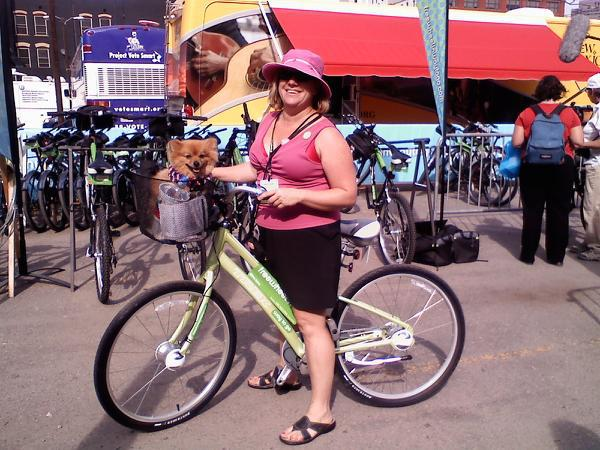Question: where are more bicycles parked?
Choices:
A. Next to the school.
B. In the bike rack.
C. By the recreation center.
D. Outside the garage.
Answer with the letter. Answer: B Question: who is wearing a blue backpack?
Choices:
A. The young student.
B. A person in the background.
C. The hiker in the forest.
D. The boy on the bike.
Answer with the letter. Answer: B Question: why is the woman wearing a hat?
Choices:
A. To keep the sun out of her eyes.
B. To protect her face from the sun.
C. To protect her hair dye from fading.
D. To keep the sun off her head.
Answer with the letter. Answer: D Question: what kind of shoes is she wearing?
Choices:
A. High heels.
B. Flip flops.
C. Sneakers.
D. Sandals.
Answer with the letter. Answer: D Question: what the woman doing?
Choices:
A. Walking on her treadmill.
B. Riding a bike.
C. Swimming laps in the pool.
D. Running laps at the gym track.
Answer with the letter. Answer: B Question: where is the truck with a red awning?
Choices:
A. Beside the house.
B. Next to the bike racks.
C. In the driveway.
D. Parked on the street.
Answer with the letter. Answer: B Question: what is the woman straddling?
Choices:
A. A red motorcycle.
B. A green bike.
C. A horse.
D. A water puddle.
Answer with the letter. Answer: B Question: what kind of top is the woman wearing?
Choices:
A. A bright pink tank.
B. A royal blue dress shirt.
C. A white halter.
D. A green scrub.
Answer with the letter. Answer: A Question: what color hat does the woman have?
Choices:
A. Red.
B. Pink.
C. Black.
D. White.
Answer with the letter. Answer: B Question: what is parked in the distance?
Choices:
A. A motorcycle.
B. A tractor.
C. A bus.
D. An eighteen wheeler.
Answer with the letter. Answer: C Question: what is in the background?
Choices:
A. A building with windows framed in white.
B. A mountain with a purple haze.
C. The sand dunes with people walking away from the beach.
D. A gray tee-pee.
Answer with the letter. Answer: A Question: what is parked in the bicycle racks?
Choices:
A. A mountain bike and a moped.
B. Many bicycles.
C. A Razor scooter and a sports bike.
D. A motorcycle and a wheelchair.
Answer with the letter. Answer: B Question: who is straddling the bike?
Choices:
A. A woman.
B. A teenage boy.
C. A college professor.
D. A set of twin brothers.
Answer with the letter. Answer: A Question: what is touching back of leg?
Choices:
A. Air.
B. Metal.
C. Bicycle pedal.
D. Sweat.
Answer with the letter. Answer: C 